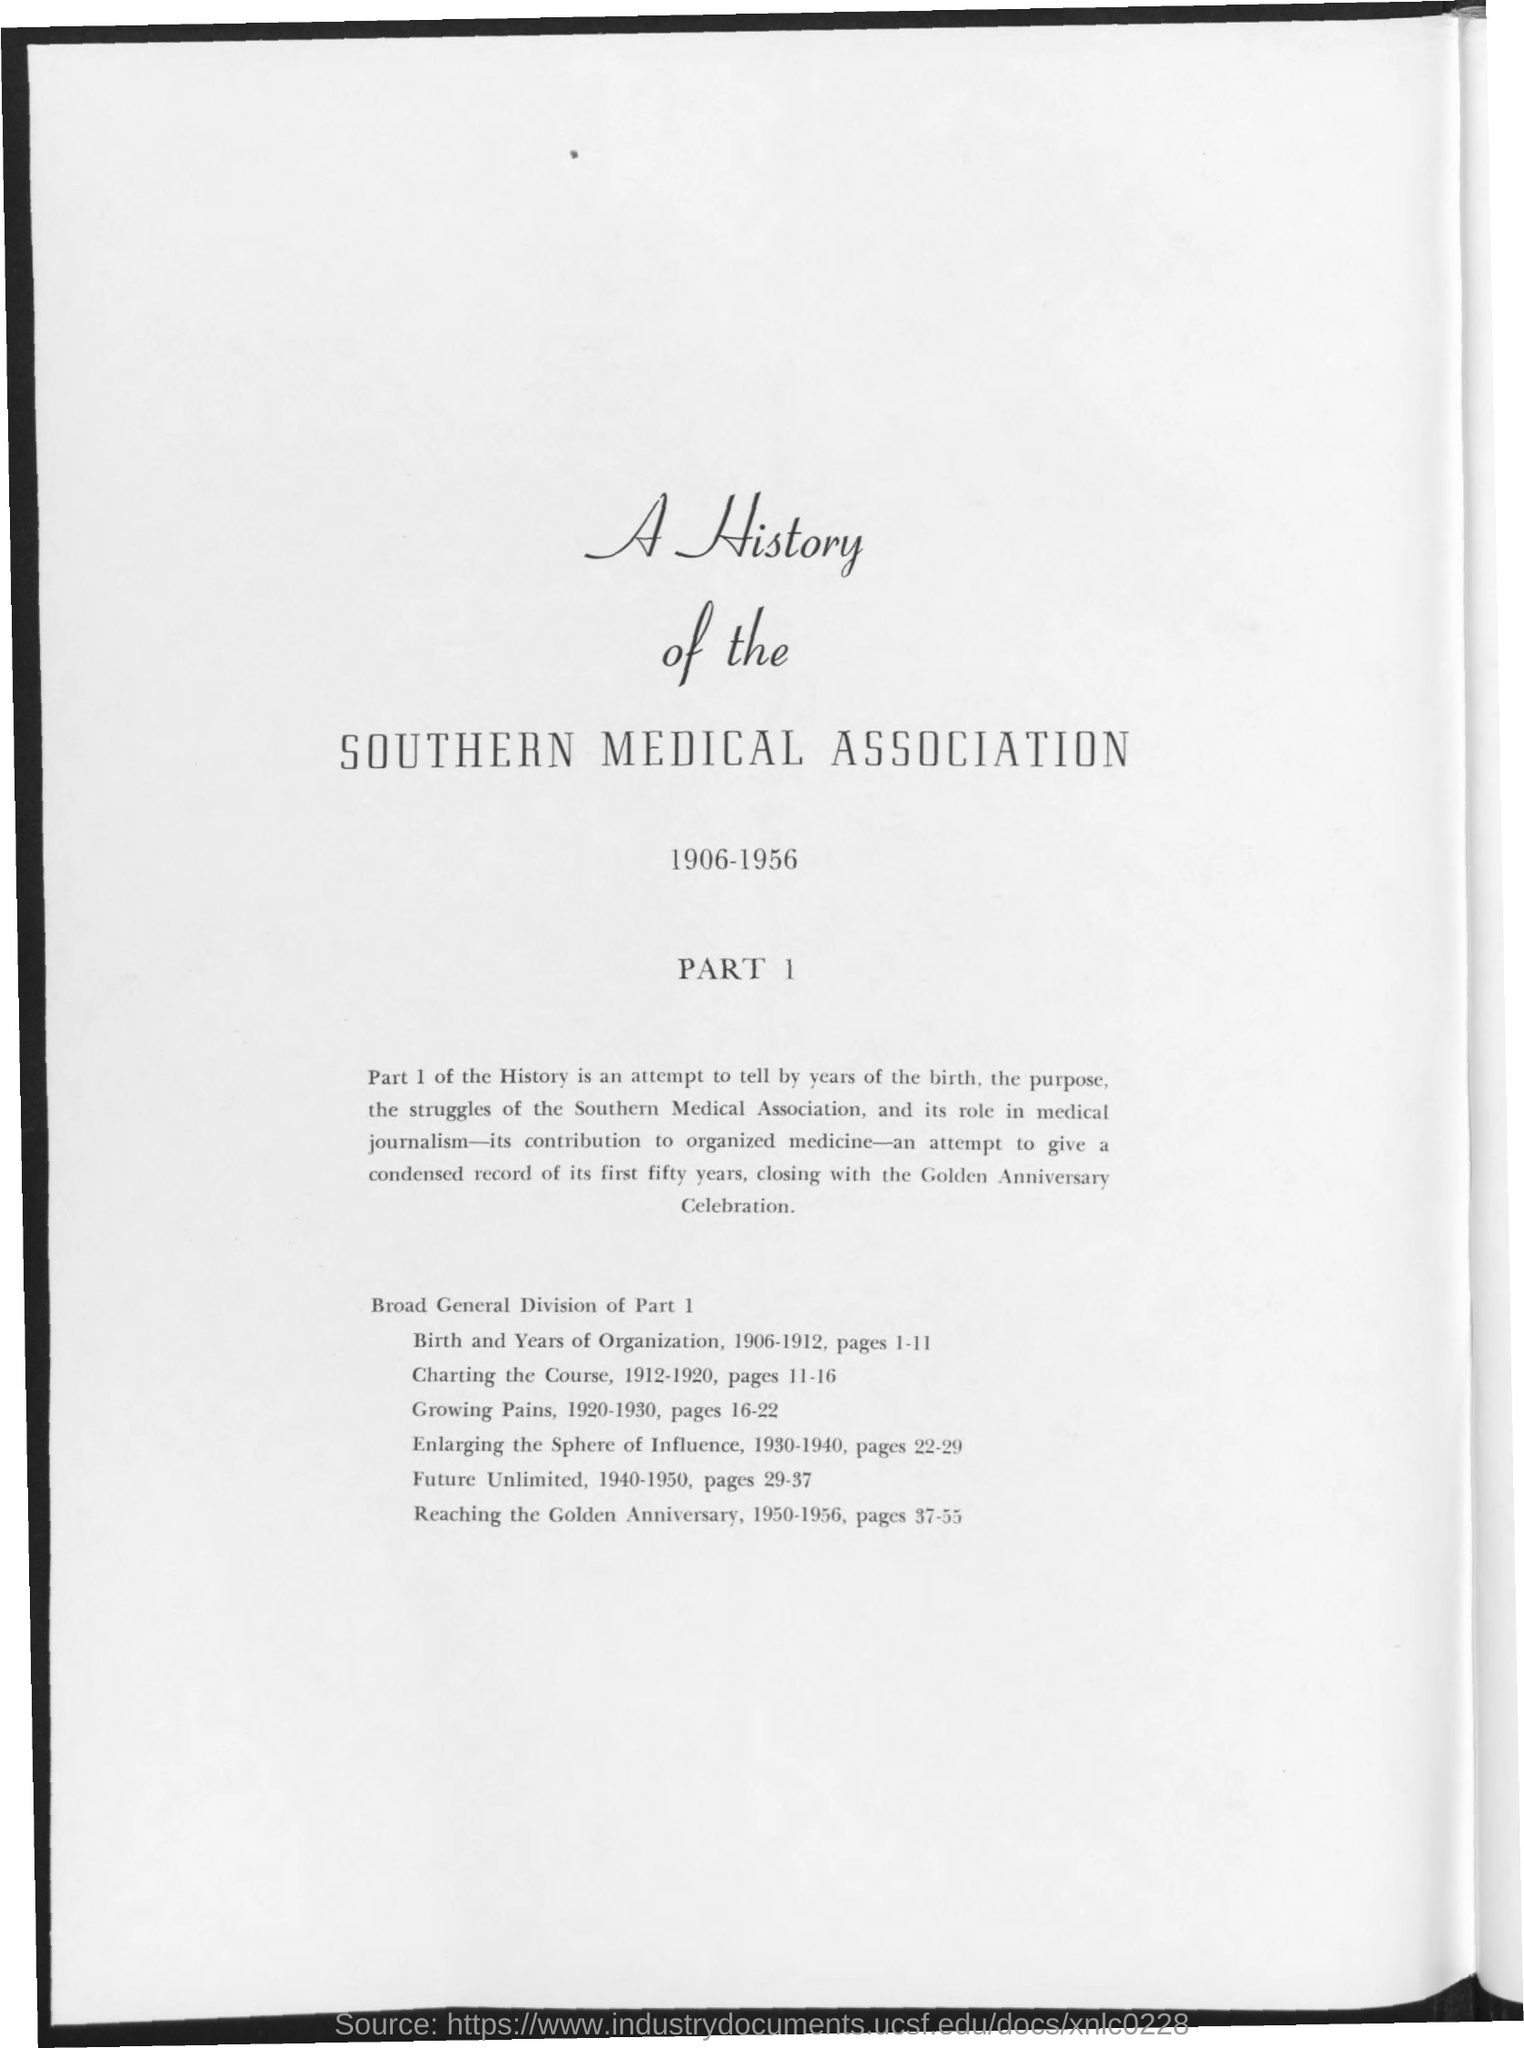What is the title of the document?
Ensure brevity in your answer.  A History of the Southern Medical Association. What is the range of years mentioned in the document?
Provide a succinct answer. 1906-1956. 